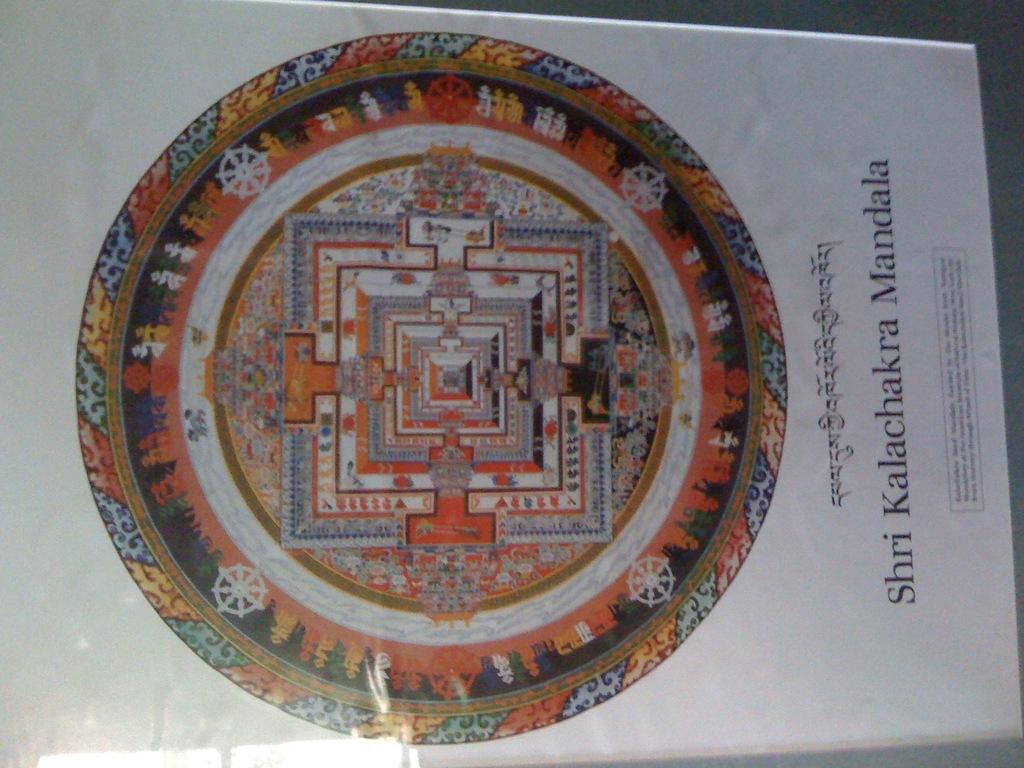What is this book about?
Offer a very short reply. Unanswerable. What is the first letter of the first english word of the title?
Provide a succinct answer. S. 